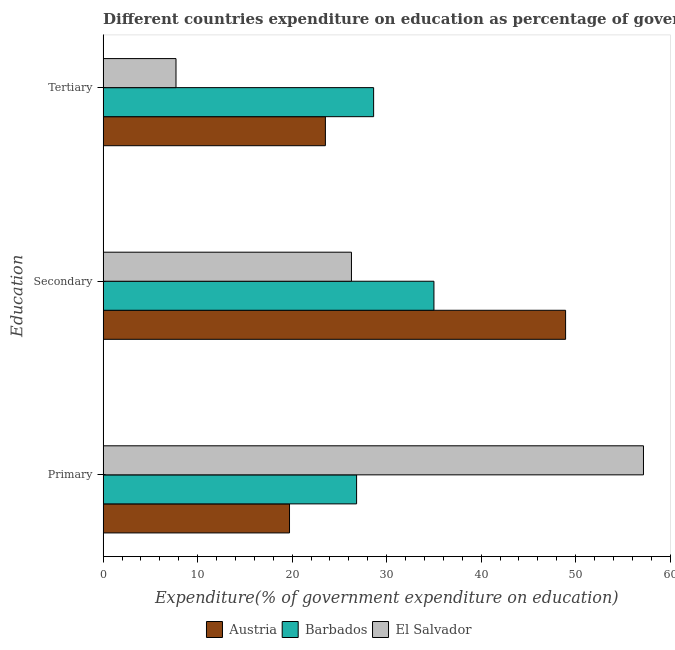How many different coloured bars are there?
Offer a very short reply. 3. Are the number of bars per tick equal to the number of legend labels?
Offer a very short reply. Yes. How many bars are there on the 2nd tick from the top?
Offer a terse response. 3. What is the label of the 3rd group of bars from the top?
Provide a succinct answer. Primary. What is the expenditure on secondary education in Barbados?
Provide a short and direct response. 35.01. Across all countries, what is the maximum expenditure on secondary education?
Your answer should be very brief. 48.94. Across all countries, what is the minimum expenditure on secondary education?
Provide a short and direct response. 26.28. In which country was the expenditure on tertiary education maximum?
Your response must be concise. Barbados. In which country was the expenditure on secondary education minimum?
Make the answer very short. El Salvador. What is the total expenditure on primary education in the graph?
Provide a short and direct response. 103.73. What is the difference between the expenditure on tertiary education in Barbados and that in Austria?
Offer a very short reply. 5.1. What is the difference between the expenditure on tertiary education in Barbados and the expenditure on primary education in Austria?
Make the answer very short. 8.9. What is the average expenditure on primary education per country?
Your answer should be compact. 34.58. What is the difference between the expenditure on tertiary education and expenditure on primary education in El Salvador?
Make the answer very short. -49.47. In how many countries, is the expenditure on secondary education greater than 28 %?
Provide a short and direct response. 2. What is the ratio of the expenditure on primary education in Barbados to that in El Salvador?
Your response must be concise. 0.47. Is the expenditure on primary education in Barbados less than that in Austria?
Provide a short and direct response. No. What is the difference between the highest and the second highest expenditure on tertiary education?
Your response must be concise. 5.1. What is the difference between the highest and the lowest expenditure on primary education?
Give a very brief answer. 37.46. What does the 2nd bar from the top in Primary represents?
Ensure brevity in your answer.  Barbados. What does the 3rd bar from the bottom in Primary represents?
Keep it short and to the point. El Salvador. Is it the case that in every country, the sum of the expenditure on primary education and expenditure on secondary education is greater than the expenditure on tertiary education?
Your response must be concise. Yes. How many bars are there?
Your answer should be compact. 9. Are all the bars in the graph horizontal?
Your answer should be very brief. Yes. Where does the legend appear in the graph?
Give a very brief answer. Bottom center. How many legend labels are there?
Your answer should be compact. 3. How are the legend labels stacked?
Ensure brevity in your answer.  Horizontal. What is the title of the graph?
Your response must be concise. Different countries expenditure on education as percentage of government expenditure. Does "Senegal" appear as one of the legend labels in the graph?
Ensure brevity in your answer.  No. What is the label or title of the X-axis?
Your response must be concise. Expenditure(% of government expenditure on education). What is the label or title of the Y-axis?
Give a very brief answer. Education. What is the Expenditure(% of government expenditure on education) in Austria in Primary?
Give a very brief answer. 19.72. What is the Expenditure(% of government expenditure on education) in Barbados in Primary?
Give a very brief answer. 26.82. What is the Expenditure(% of government expenditure on education) in El Salvador in Primary?
Provide a succinct answer. 57.18. What is the Expenditure(% of government expenditure on education) in Austria in Secondary?
Give a very brief answer. 48.94. What is the Expenditure(% of government expenditure on education) in Barbados in Secondary?
Ensure brevity in your answer.  35.01. What is the Expenditure(% of government expenditure on education) of El Salvador in Secondary?
Offer a terse response. 26.28. What is the Expenditure(% of government expenditure on education) of Austria in Tertiary?
Your answer should be compact. 23.52. What is the Expenditure(% of government expenditure on education) in Barbados in Tertiary?
Keep it short and to the point. 28.62. What is the Expenditure(% of government expenditure on education) in El Salvador in Tertiary?
Your response must be concise. 7.71. Across all Education, what is the maximum Expenditure(% of government expenditure on education) in Austria?
Offer a terse response. 48.94. Across all Education, what is the maximum Expenditure(% of government expenditure on education) of Barbados?
Make the answer very short. 35.01. Across all Education, what is the maximum Expenditure(% of government expenditure on education) of El Salvador?
Give a very brief answer. 57.18. Across all Education, what is the minimum Expenditure(% of government expenditure on education) of Austria?
Your response must be concise. 19.72. Across all Education, what is the minimum Expenditure(% of government expenditure on education) of Barbados?
Provide a short and direct response. 26.82. Across all Education, what is the minimum Expenditure(% of government expenditure on education) of El Salvador?
Offer a terse response. 7.71. What is the total Expenditure(% of government expenditure on education) of Austria in the graph?
Your response must be concise. 92.18. What is the total Expenditure(% of government expenditure on education) in Barbados in the graph?
Provide a short and direct response. 90.45. What is the total Expenditure(% of government expenditure on education) in El Salvador in the graph?
Your answer should be very brief. 91.17. What is the difference between the Expenditure(% of government expenditure on education) in Austria in Primary and that in Secondary?
Ensure brevity in your answer.  -29.22. What is the difference between the Expenditure(% of government expenditure on education) in Barbados in Primary and that in Secondary?
Provide a succinct answer. -8.19. What is the difference between the Expenditure(% of government expenditure on education) in El Salvador in Primary and that in Secondary?
Keep it short and to the point. 30.9. What is the difference between the Expenditure(% of government expenditure on education) in Austria in Primary and that in Tertiary?
Make the answer very short. -3.8. What is the difference between the Expenditure(% of government expenditure on education) of Barbados in Primary and that in Tertiary?
Give a very brief answer. -1.8. What is the difference between the Expenditure(% of government expenditure on education) of El Salvador in Primary and that in Tertiary?
Your answer should be very brief. 49.47. What is the difference between the Expenditure(% of government expenditure on education) in Austria in Secondary and that in Tertiary?
Provide a succinct answer. 25.42. What is the difference between the Expenditure(% of government expenditure on education) of Barbados in Secondary and that in Tertiary?
Provide a succinct answer. 6.38. What is the difference between the Expenditure(% of government expenditure on education) of El Salvador in Secondary and that in Tertiary?
Your answer should be very brief. 18.57. What is the difference between the Expenditure(% of government expenditure on education) of Austria in Primary and the Expenditure(% of government expenditure on education) of Barbados in Secondary?
Provide a short and direct response. -15.28. What is the difference between the Expenditure(% of government expenditure on education) in Austria in Primary and the Expenditure(% of government expenditure on education) in El Salvador in Secondary?
Offer a very short reply. -6.56. What is the difference between the Expenditure(% of government expenditure on education) of Barbados in Primary and the Expenditure(% of government expenditure on education) of El Salvador in Secondary?
Offer a terse response. 0.54. What is the difference between the Expenditure(% of government expenditure on education) of Austria in Primary and the Expenditure(% of government expenditure on education) of Barbados in Tertiary?
Make the answer very short. -8.9. What is the difference between the Expenditure(% of government expenditure on education) in Austria in Primary and the Expenditure(% of government expenditure on education) in El Salvador in Tertiary?
Your answer should be very brief. 12.01. What is the difference between the Expenditure(% of government expenditure on education) in Barbados in Primary and the Expenditure(% of government expenditure on education) in El Salvador in Tertiary?
Offer a very short reply. 19.11. What is the difference between the Expenditure(% of government expenditure on education) in Austria in Secondary and the Expenditure(% of government expenditure on education) in Barbados in Tertiary?
Keep it short and to the point. 20.31. What is the difference between the Expenditure(% of government expenditure on education) of Austria in Secondary and the Expenditure(% of government expenditure on education) of El Salvador in Tertiary?
Ensure brevity in your answer.  41.23. What is the difference between the Expenditure(% of government expenditure on education) of Barbados in Secondary and the Expenditure(% of government expenditure on education) of El Salvador in Tertiary?
Provide a short and direct response. 27.3. What is the average Expenditure(% of government expenditure on education) of Austria per Education?
Your answer should be compact. 30.73. What is the average Expenditure(% of government expenditure on education) of Barbados per Education?
Your answer should be very brief. 30.15. What is the average Expenditure(% of government expenditure on education) of El Salvador per Education?
Give a very brief answer. 30.39. What is the difference between the Expenditure(% of government expenditure on education) in Austria and Expenditure(% of government expenditure on education) in Barbados in Primary?
Offer a very short reply. -7.1. What is the difference between the Expenditure(% of government expenditure on education) in Austria and Expenditure(% of government expenditure on education) in El Salvador in Primary?
Offer a terse response. -37.46. What is the difference between the Expenditure(% of government expenditure on education) of Barbados and Expenditure(% of government expenditure on education) of El Salvador in Primary?
Keep it short and to the point. -30.36. What is the difference between the Expenditure(% of government expenditure on education) in Austria and Expenditure(% of government expenditure on education) in Barbados in Secondary?
Give a very brief answer. 13.93. What is the difference between the Expenditure(% of government expenditure on education) of Austria and Expenditure(% of government expenditure on education) of El Salvador in Secondary?
Your answer should be very brief. 22.66. What is the difference between the Expenditure(% of government expenditure on education) in Barbados and Expenditure(% of government expenditure on education) in El Salvador in Secondary?
Your response must be concise. 8.73. What is the difference between the Expenditure(% of government expenditure on education) in Austria and Expenditure(% of government expenditure on education) in Barbados in Tertiary?
Ensure brevity in your answer.  -5.1. What is the difference between the Expenditure(% of government expenditure on education) in Austria and Expenditure(% of government expenditure on education) in El Salvador in Tertiary?
Provide a short and direct response. 15.81. What is the difference between the Expenditure(% of government expenditure on education) of Barbados and Expenditure(% of government expenditure on education) of El Salvador in Tertiary?
Offer a very short reply. 20.91. What is the ratio of the Expenditure(% of government expenditure on education) of Austria in Primary to that in Secondary?
Make the answer very short. 0.4. What is the ratio of the Expenditure(% of government expenditure on education) in Barbados in Primary to that in Secondary?
Offer a very short reply. 0.77. What is the ratio of the Expenditure(% of government expenditure on education) of El Salvador in Primary to that in Secondary?
Provide a succinct answer. 2.18. What is the ratio of the Expenditure(% of government expenditure on education) of Austria in Primary to that in Tertiary?
Provide a succinct answer. 0.84. What is the ratio of the Expenditure(% of government expenditure on education) of Barbados in Primary to that in Tertiary?
Keep it short and to the point. 0.94. What is the ratio of the Expenditure(% of government expenditure on education) of El Salvador in Primary to that in Tertiary?
Offer a very short reply. 7.42. What is the ratio of the Expenditure(% of government expenditure on education) of Austria in Secondary to that in Tertiary?
Provide a succinct answer. 2.08. What is the ratio of the Expenditure(% of government expenditure on education) of Barbados in Secondary to that in Tertiary?
Make the answer very short. 1.22. What is the ratio of the Expenditure(% of government expenditure on education) in El Salvador in Secondary to that in Tertiary?
Offer a terse response. 3.41. What is the difference between the highest and the second highest Expenditure(% of government expenditure on education) of Austria?
Your response must be concise. 25.42. What is the difference between the highest and the second highest Expenditure(% of government expenditure on education) in Barbados?
Your answer should be compact. 6.38. What is the difference between the highest and the second highest Expenditure(% of government expenditure on education) of El Salvador?
Keep it short and to the point. 30.9. What is the difference between the highest and the lowest Expenditure(% of government expenditure on education) of Austria?
Offer a terse response. 29.22. What is the difference between the highest and the lowest Expenditure(% of government expenditure on education) of Barbados?
Give a very brief answer. 8.19. What is the difference between the highest and the lowest Expenditure(% of government expenditure on education) of El Salvador?
Provide a short and direct response. 49.47. 